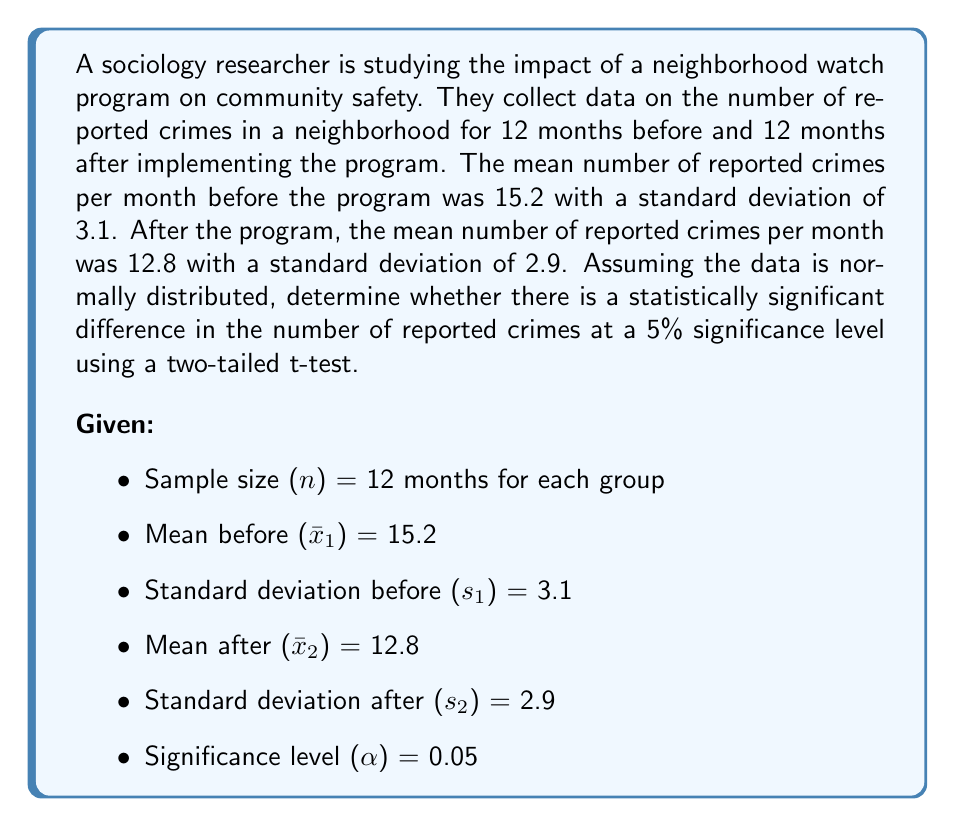Show me your answer to this math problem. To determine if there is a statistically significant difference, we'll use a two-sample t-test. Here are the steps:

1. Calculate the pooled standard deviation:
   $$s_p = \sqrt{\frac{(n_1 - 1)s_1^2 + (n_2 - 1)s_2^2}{n_1 + n_2 - 2}}$$
   $$s_p = \sqrt{\frac{(12 - 1)(3.1)^2 + (12 - 1)(2.9)^2}{12 + 12 - 2}} = 3.00$$

2. Calculate the t-statistic:
   $$t = \frac{\bar{x}_1 - \bar{x}_2}{s_p\sqrt{\frac{2}{n}}}$$
   $$t = \frac{15.2 - 12.8}{3.00\sqrt{\frac{2}{12}}} = 2.19$$

3. Determine the degrees of freedom:
   $df = n_1 + n_2 - 2 = 12 + 12 - 2 = 22$

4. Find the critical t-value for a two-tailed test at $\alpha = 0.05$ and $df = 22$:
   $t_{critical} = \pm 2.074$

5. Compare the calculated t-statistic to the critical t-value:
   $|2.19| > 2.074$

6. Calculate the p-value:
   Using a t-distribution calculator, we find that the p-value for $t = 2.19$ and $df = 22$ is approximately 0.0392.

Since $|t| > t_{critical}$ and $p < \alpha$, we reject the null hypothesis.
Answer: There is a statistically significant difference in the number of reported crimes before and after implementing the neighborhood watch program (t(22) = 2.19, p = 0.0392 < 0.05). This suggests that the program may have had a positive impact on community safety. 